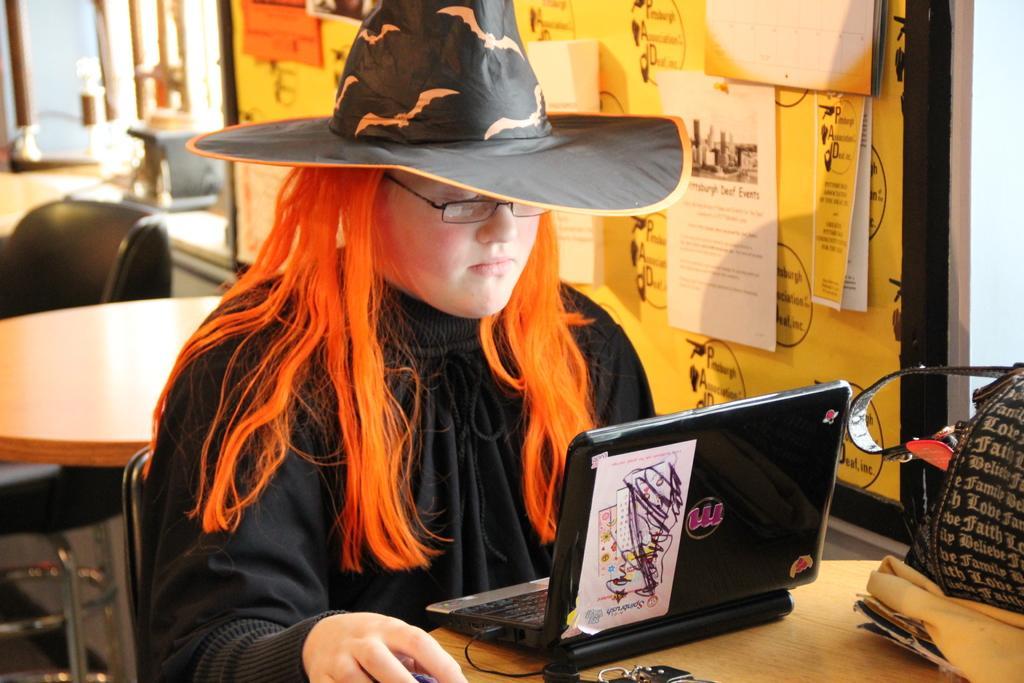Describe this image in one or two sentences. In this picture I can see a woman wearing hat and sitting in front of the table on which I can see laptop, bags and some objects, side there is a board with some paper and behind I can see some tables, chairs. 